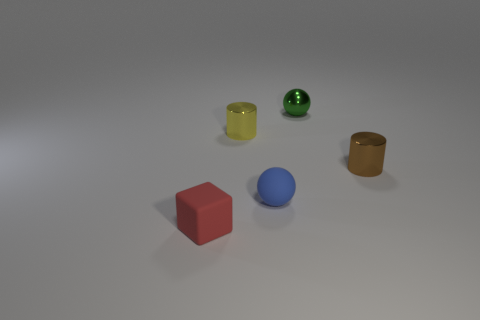Is there a yellow shiny thing that has the same shape as the tiny red rubber thing?
Keep it short and to the point. No. How many small yellow objects are to the left of the small rubber object that is in front of the small matte thing that is behind the red thing?
Offer a very short reply. 0. How many things are metallic things behind the tiny brown metal cylinder or small shiny things to the right of the tiny blue ball?
Your response must be concise. 3. Is the number of blue objects on the left side of the small red matte object greater than the number of green shiny things that are to the left of the tiny yellow object?
Offer a terse response. No. There is a object in front of the tiny blue rubber thing that is to the right of the shiny cylinder on the left side of the small matte ball; what is it made of?
Make the answer very short. Rubber. There is a metal thing in front of the yellow cylinder; is its shape the same as the tiny metallic thing that is left of the small green thing?
Give a very brief answer. Yes. Are there any brown objects that have the same size as the green ball?
Your answer should be very brief. Yes. What number of cyan things are either large matte cubes or small matte blocks?
Ensure brevity in your answer.  0. What number of other matte spheres have the same color as the matte ball?
Offer a terse response. 0. Is there any other thing that has the same shape as the blue thing?
Provide a short and direct response. Yes. 